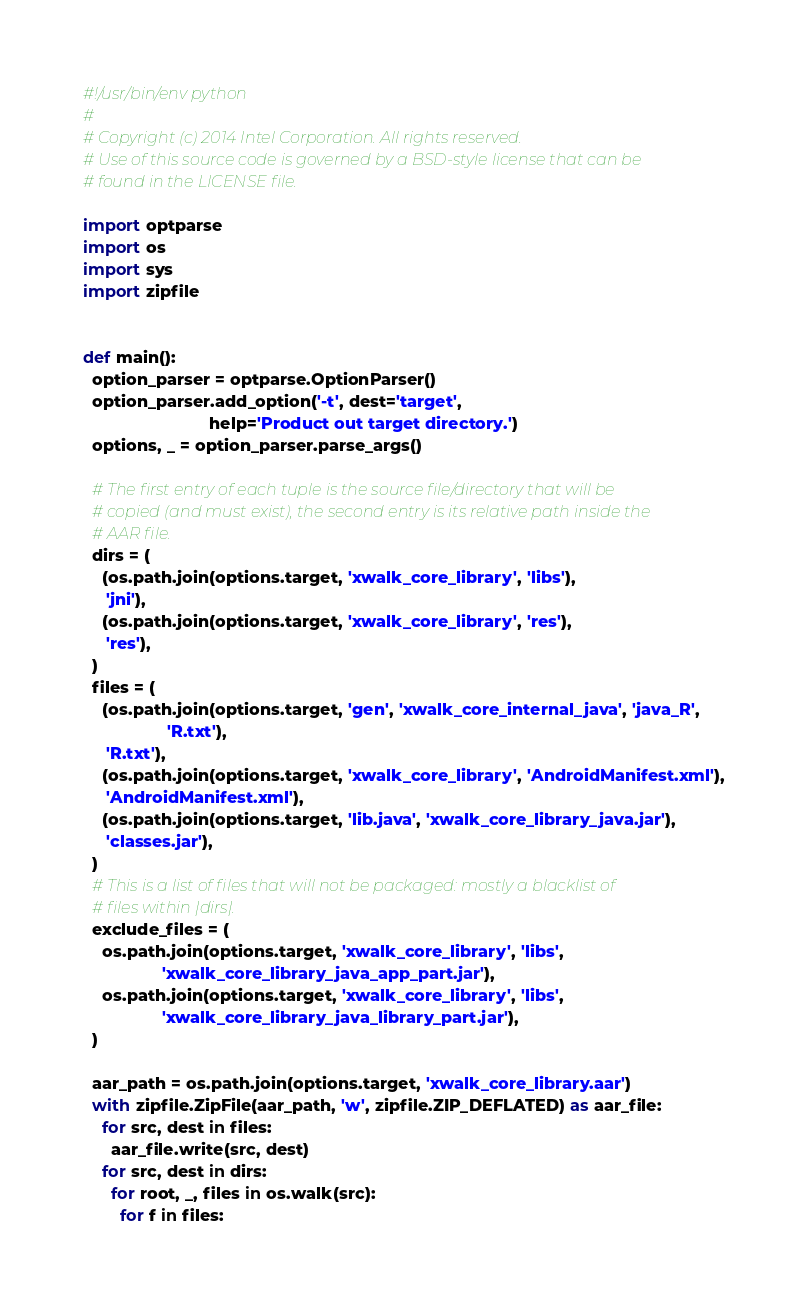<code> <loc_0><loc_0><loc_500><loc_500><_Python_>#!/usr/bin/env python
#
# Copyright (c) 2014 Intel Corporation. All rights reserved.
# Use of this source code is governed by a BSD-style license that can be
# found in the LICENSE file.

import optparse
import os
import sys
import zipfile


def main():
  option_parser = optparse.OptionParser()
  option_parser.add_option('-t', dest='target',
                           help='Product out target directory.')
  options, _ = option_parser.parse_args()

  # The first entry of each tuple is the source file/directory that will be
  # copied (and must exist), the second entry is its relative path inside the
  # AAR file.
  dirs = (
    (os.path.join(options.target, 'xwalk_core_library', 'libs'),
     'jni'),
    (os.path.join(options.target, 'xwalk_core_library', 'res'),
     'res'),
  )
  files = (
    (os.path.join(options.target, 'gen', 'xwalk_core_internal_java', 'java_R',
                  'R.txt'),
     'R.txt'),
    (os.path.join(options.target, 'xwalk_core_library', 'AndroidManifest.xml'),
     'AndroidManifest.xml'),
    (os.path.join(options.target, 'lib.java', 'xwalk_core_library_java.jar'),
     'classes.jar'),
  )
  # This is a list of files that will not be packaged: mostly a blacklist of
  # files within |dirs|.
  exclude_files = (
    os.path.join(options.target, 'xwalk_core_library', 'libs',
                 'xwalk_core_library_java_app_part.jar'),
    os.path.join(options.target, 'xwalk_core_library', 'libs',
                 'xwalk_core_library_java_library_part.jar'),
  )

  aar_path = os.path.join(options.target, 'xwalk_core_library.aar')
  with zipfile.ZipFile(aar_path, 'w', zipfile.ZIP_DEFLATED) as aar_file:
    for src, dest in files:
      aar_file.write(src, dest)
    for src, dest in dirs:
      for root, _, files in os.walk(src):
        for f in files:</code> 